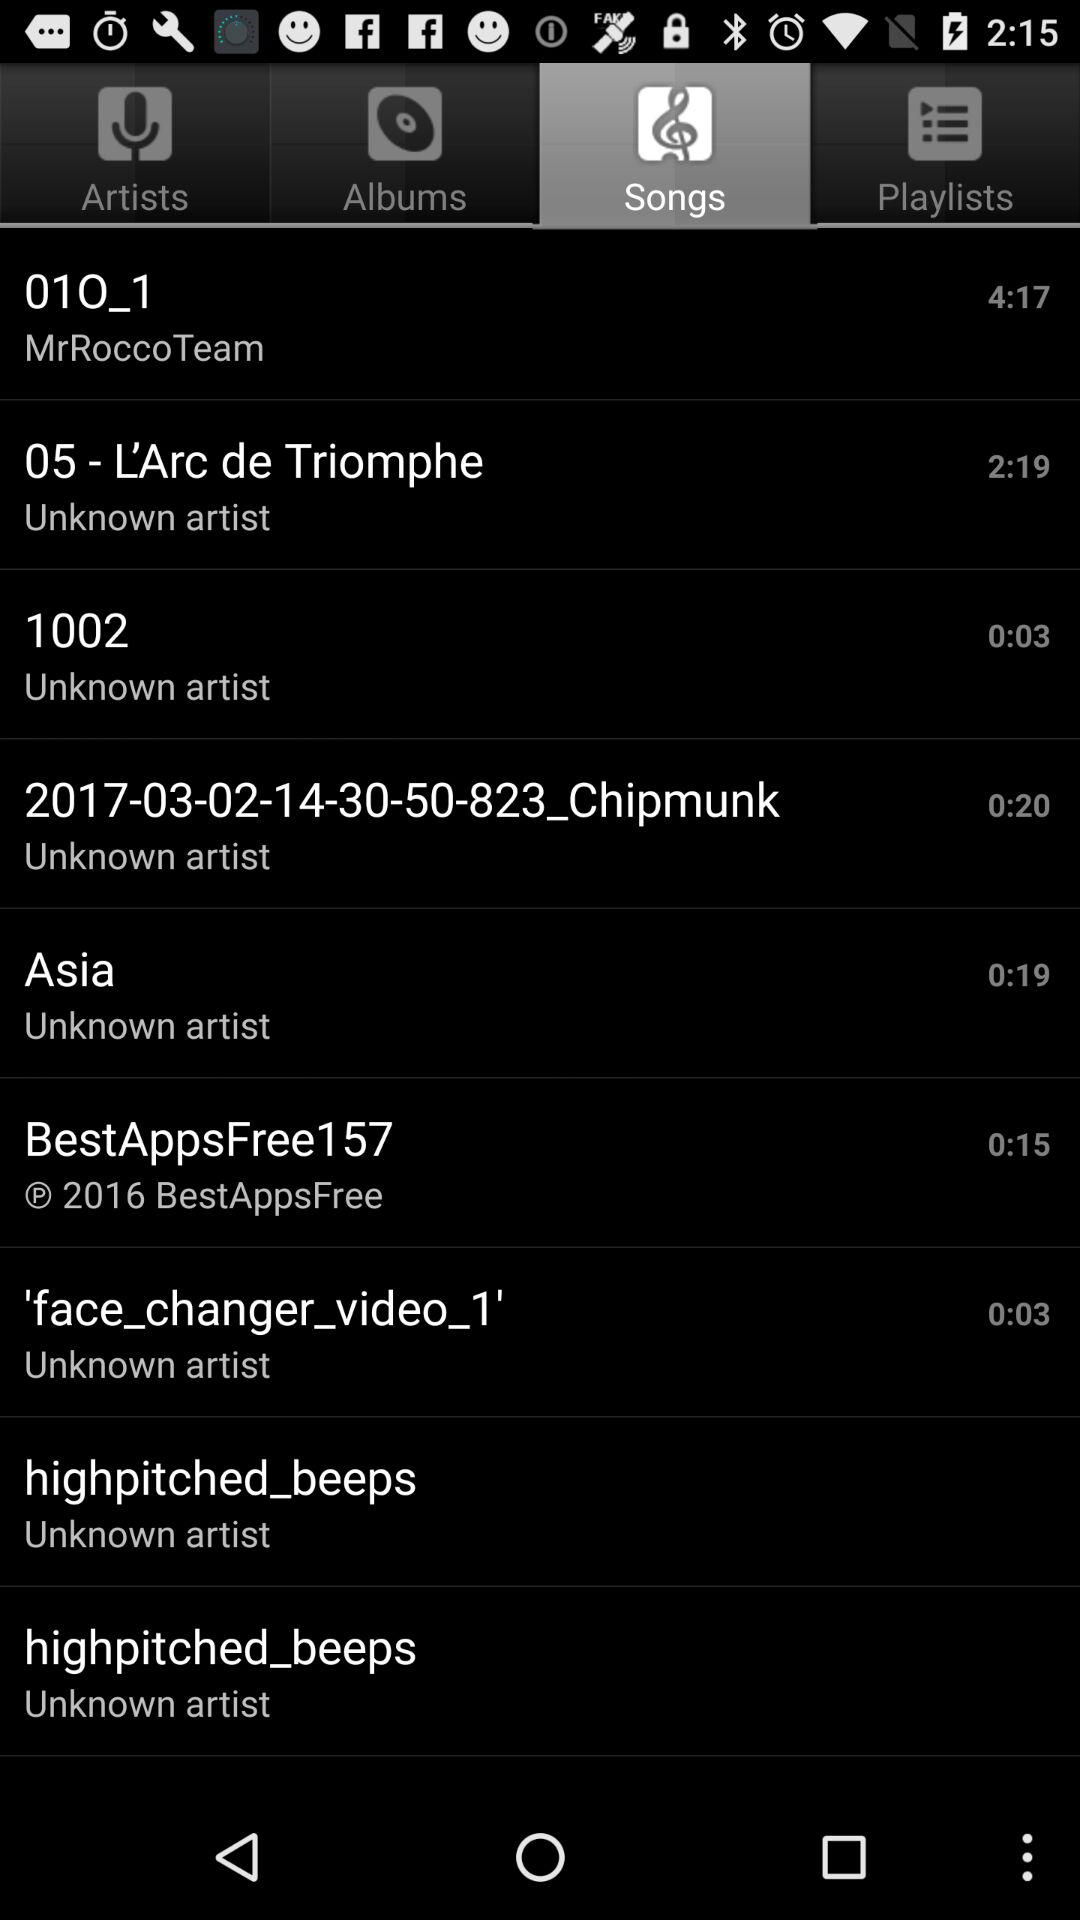Which song has the largest duration time?
When the provided information is insufficient, respond with <no answer>. <no answer> 